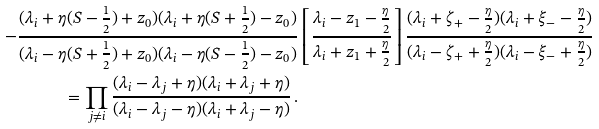Convert formula to latex. <formula><loc_0><loc_0><loc_500><loc_500>- \frac { ( \lambda _ { i } + \eta ( S - \frac { 1 } { 2 } ) + z _ { 0 } ) ( \lambda _ { i } + \eta ( S + \frac { 1 } { 2 } ) - z _ { 0 } ) } { ( \lambda _ { i } - \eta ( S + \frac { 1 } { 2 } ) + z _ { 0 } ) ( \lambda _ { i } - \eta ( S - \frac { 1 } { 2 } ) - z _ { 0 } ) } & \left [ \frac { \lambda _ { i } - z _ { 1 } - \frac { \eta } { 2 } } { \lambda _ { i } + z _ { 1 } + \frac { \eta } { 2 } } \right ] \frac { ( \lambda _ { i } + \zeta _ { + } - \frac { \eta } { 2 } ) ( \lambda _ { i } + \xi _ { - } - \frac { \eta } { 2 } ) } { ( \lambda _ { i } - \zeta _ { + } + \frac { \eta } { 2 } ) ( \lambda _ { i } - \xi _ { - } + \frac { \eta } { 2 } ) } \\ = \prod _ { j \neq i } \frac { ( \lambda _ { i } - \lambda _ { j } + \eta ) ( \lambda _ { i } + \lambda _ { j } + \eta ) } { ( \lambda _ { i } - \lambda _ { j } - \eta ) ( \lambda _ { i } + \lambda _ { j } - \eta ) } \, .</formula> 